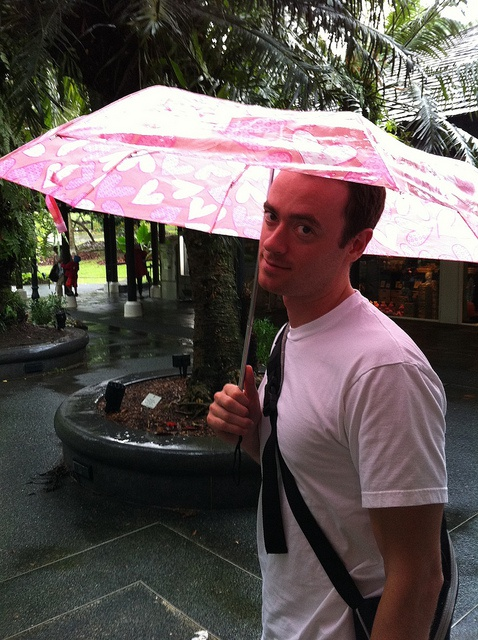Describe the objects in this image and their specific colors. I can see people in black, gray, maroon, and darkgray tones, umbrella in black, white, pink, and lightpink tones, backpack in black and gray tones, handbag in black and gray tones, and people in black, gray, and maroon tones in this image. 